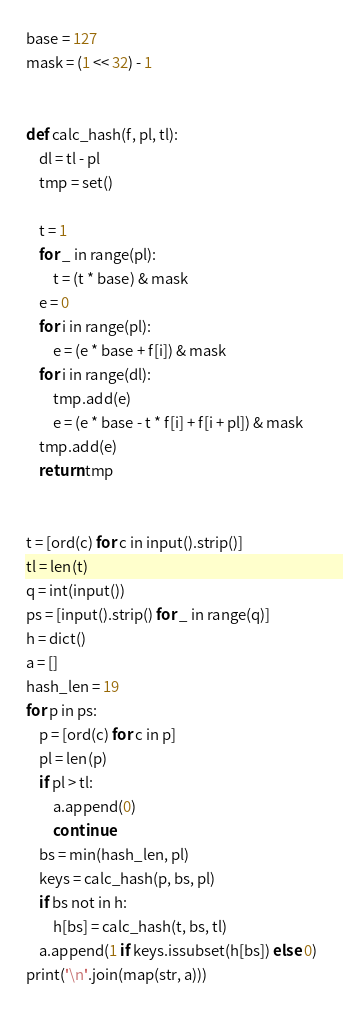Convert code to text. <code><loc_0><loc_0><loc_500><loc_500><_Python_>base = 127
mask = (1 << 32) - 1


def calc_hash(f, pl, tl):
    dl = tl - pl
    tmp = set()

    t = 1
    for _ in range(pl):
        t = (t * base) & mask
    e = 0
    for i in range(pl):
        e = (e * base + f[i]) & mask
    for i in range(dl):
        tmp.add(e)
        e = (e * base - t * f[i] + f[i + pl]) & mask
    tmp.add(e)
    return tmp


t = [ord(c) for c in input().strip()]
tl = len(t)
q = int(input())
ps = [input().strip() for _ in range(q)]
h = dict()
a = []
hash_len = 19
for p in ps:
    p = [ord(c) for c in p]
    pl = len(p)
    if pl > tl:
        a.append(0)
        continue
    bs = min(hash_len, pl)
    keys = calc_hash(p, bs, pl)
    if bs not in h:
        h[bs] = calc_hash(t, bs, tl)
    a.append(1 if keys.issubset(h[bs]) else 0)
print('\n'.join(map(str, a)))</code> 